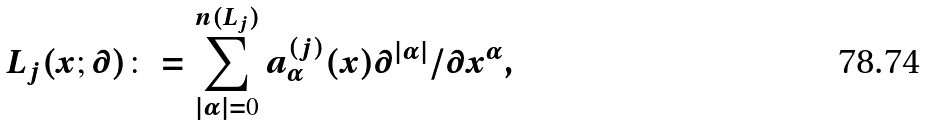<formula> <loc_0><loc_0><loc_500><loc_500>L _ { j } ( x ; \partial ) \colon = \sum _ { | \alpha | = 0 } ^ { n ( L _ { j } ) } a _ { \alpha } ^ { ( j ) } ( x ) \partial ^ { | \alpha | } / \partial x ^ { \alpha } ,</formula> 